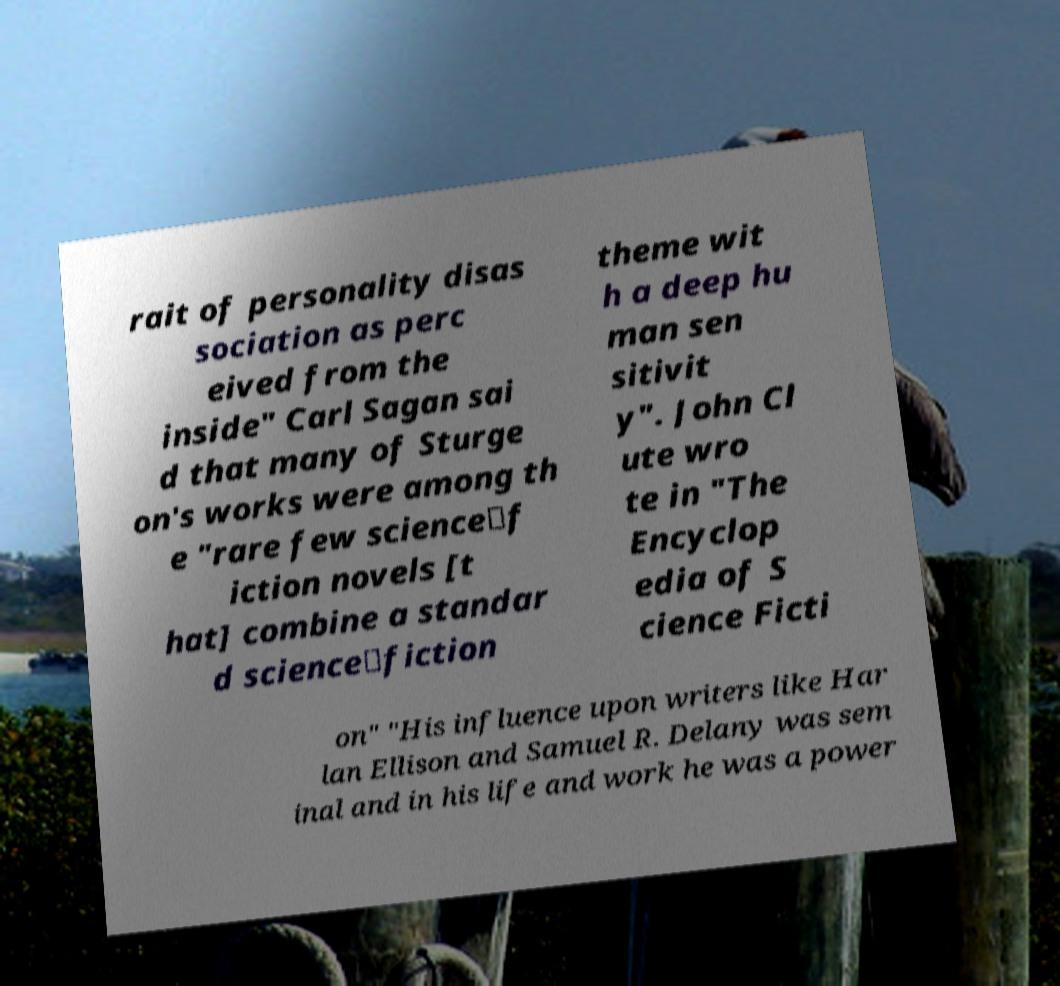There's text embedded in this image that I need extracted. Can you transcribe it verbatim? rait of personality disas sociation as perc eived from the inside" Carl Sagan sai d that many of Sturge on's works were among th e "rare few science‐f iction novels [t hat] combine a standar d science‐fiction theme wit h a deep hu man sen sitivit y". John Cl ute wro te in "The Encyclop edia of S cience Ficti on" "His influence upon writers like Har lan Ellison and Samuel R. Delany was sem inal and in his life and work he was a power 